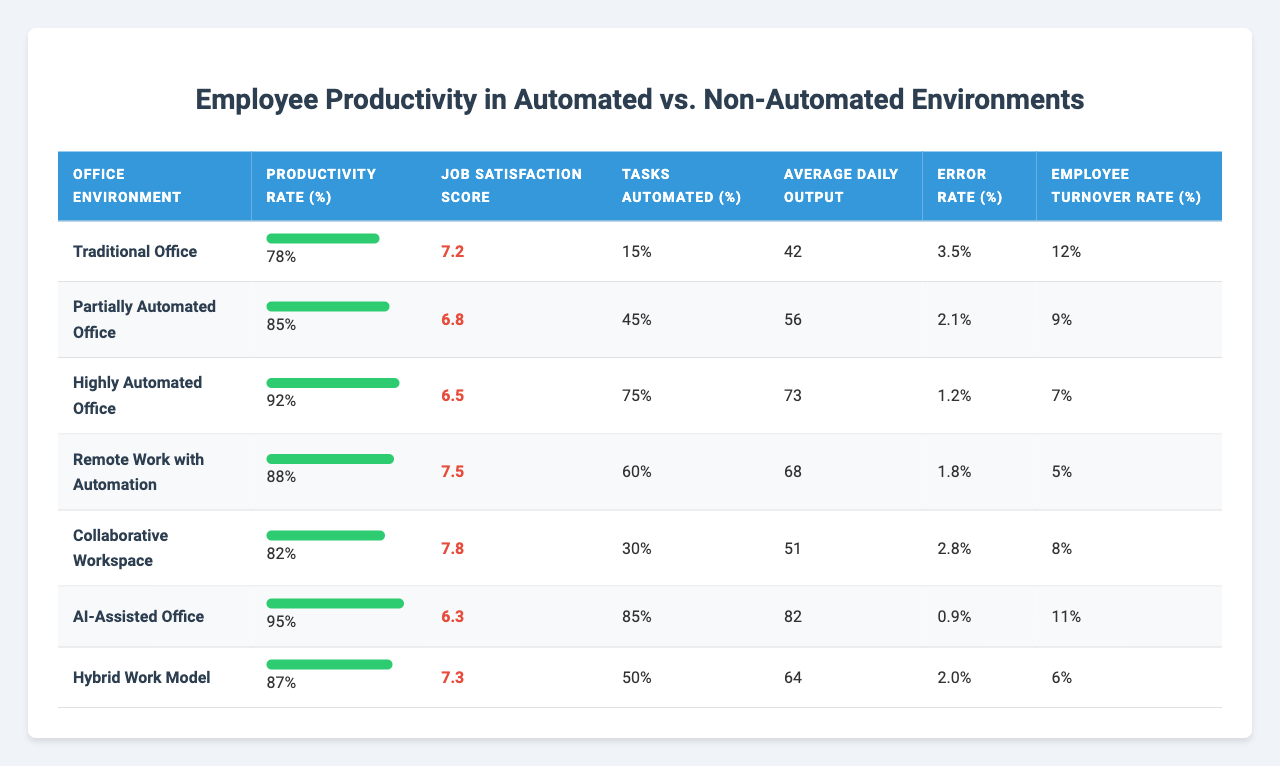What is the productivity rate in the Highly Automated Office? In the row that corresponds to the Highly Automated Office, the productivity rate is listed as 92%.
Answer: 92% Which office environment has the lowest job satisfaction score? By looking at the job satisfaction scores, the Highly Automated Office has the lowest score of 6.5.
Answer: 6.5 What is the average productivity rate for all office environments? To find the average, sum the productivity rates: 78 + 85 + 92 + 88 + 82 + 95 + 87 = 607, then divide by 7 (the number of environments): 607 / 7 = 86.71, rounded to 2 decimal places gives an average rate of approximately 86.71%.
Answer: 86.71% Is the error rate higher in Traditional Offices compared to Highly Automated Offices? The Traditional Office has an error rate of 3.5%, while the Highly Automated Office has an error rate of 1.2%. Thus, the error rate is higher in the Traditional Office.
Answer: Yes How much is the difference in job satisfaction scores between Partially Automated Office and AI-Assisted Office? The job satisfaction score for Partially Automated Office is 6.8, while for AI-Assisted Office it is 6.3. The difference is 6.8 - 6.3 = 0.5.
Answer: 0.5 What percentage of tasks are automated in the Remote Work with Automation environment? In the row for Remote Work with Automation, the percentage of tasks automated is reported as 60%.
Answer: 60% Which office environment has the highest employee turnover rate and what is its value? By examining the turnover rates, the Traditional Office has the highest rate at 12%.
Answer: 12% Is there a relationship between productivity rates and job satisfaction scores in automated environments? In the automated environments, productivity tends to be higher, while job satisfaction scores are somewhat lower. For instance, the AI-Assisted Office has the highest productivity rate of 95% but the lowest job satisfaction score of 6.3. This indicates an inverse relationship in this scenario.
Answer: Yes What is the total average daily output for offices with automation? We identify the offices with automation: Partially Automated, Highly Automated, Remote Work with Automation, AI-Assisted, and Hybrid Work Model, whose average daily outputs are 56, 73, 68, 82, and 64, respectively. Summing these gives 56 + 73 + 68 + 82 + 64 = 343, and dividing by 5 gives an average of 68.6.
Answer: 68.6 Does employee turnover decrease as the automation level increases? By analyzing the table data, the turnover rates are: 12%, 9%, 7%, 5%, 8%, 11%, and 6%. There is a general decreasing pattern as the level of automation increases, but not consistently for every environment. Hence, while it trends downwards, there are exceptions.
Answer: Yes 